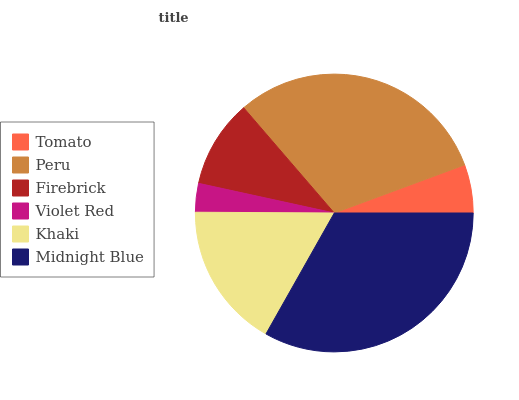Is Violet Red the minimum?
Answer yes or no. Yes. Is Midnight Blue the maximum?
Answer yes or no. Yes. Is Peru the minimum?
Answer yes or no. No. Is Peru the maximum?
Answer yes or no. No. Is Peru greater than Tomato?
Answer yes or no. Yes. Is Tomato less than Peru?
Answer yes or no. Yes. Is Tomato greater than Peru?
Answer yes or no. No. Is Peru less than Tomato?
Answer yes or no. No. Is Khaki the high median?
Answer yes or no. Yes. Is Firebrick the low median?
Answer yes or no. Yes. Is Peru the high median?
Answer yes or no. No. Is Peru the low median?
Answer yes or no. No. 